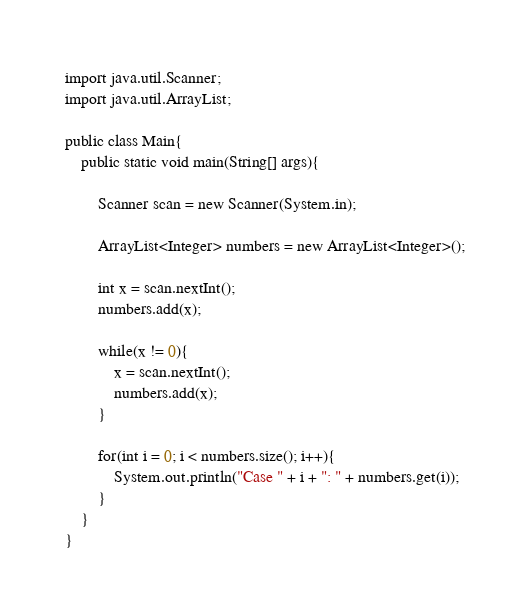<code> <loc_0><loc_0><loc_500><loc_500><_Java_>import java.util.Scanner;
import java.util.ArrayList;

public class Main{
	public static void main(String[] args){

		Scanner scan = new Scanner(System.in);

		ArrayList<Integer> numbers = new ArrayList<Integer>();

		int x = scan.nextInt();
		numbers.add(x);

		while(x != 0){
			x = scan.nextInt();
			numbers.add(x);
		}

		for(int i = 0; i < numbers.size(); i++){
			System.out.println("Case " + i + ": " + numbers.get(i));
		}
	}
}</code> 